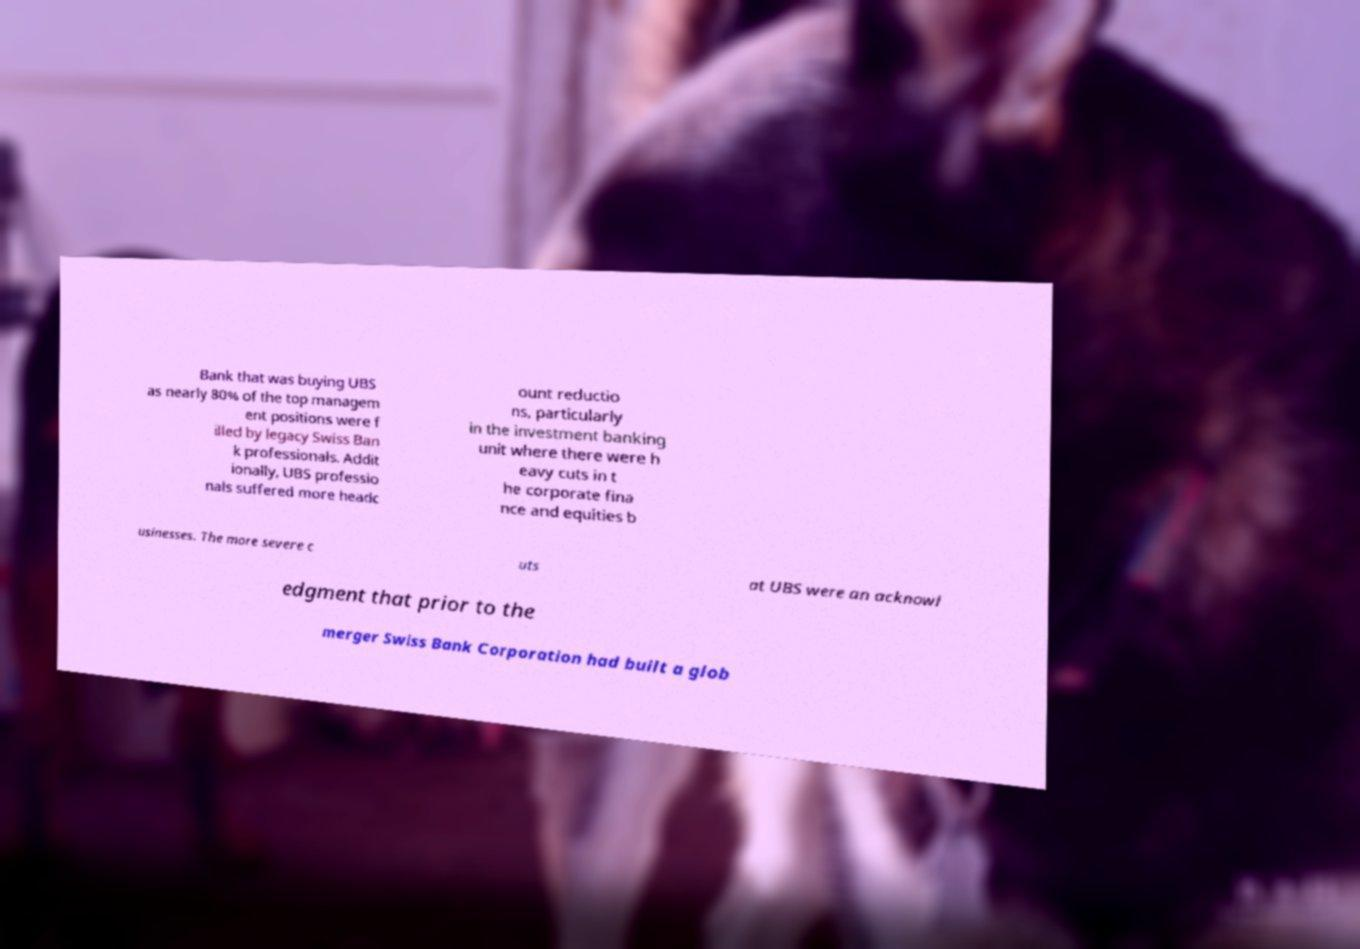Please read and relay the text visible in this image. What does it say? Bank that was buying UBS as nearly 80% of the top managem ent positions were f illed by legacy Swiss Ban k professionals. Addit ionally, UBS professio nals suffered more headc ount reductio ns, particularly in the investment banking unit where there were h eavy cuts in t he corporate fina nce and equities b usinesses. The more severe c uts at UBS were an acknowl edgment that prior to the merger Swiss Bank Corporation had built a glob 